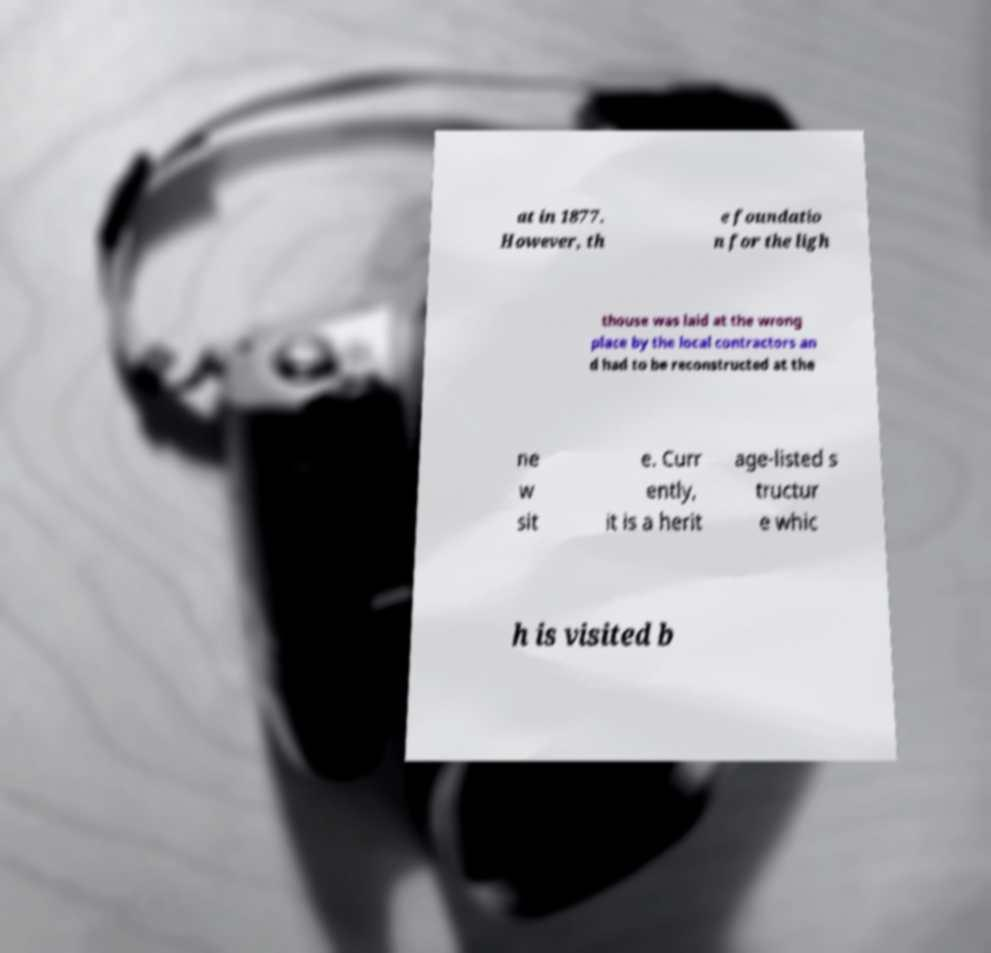Could you extract and type out the text from this image? at in 1877. However, th e foundatio n for the ligh thouse was laid at the wrong place by the local contractors an d had to be reconstructed at the ne w sit e. Curr ently, it is a herit age-listed s tructur e whic h is visited b 